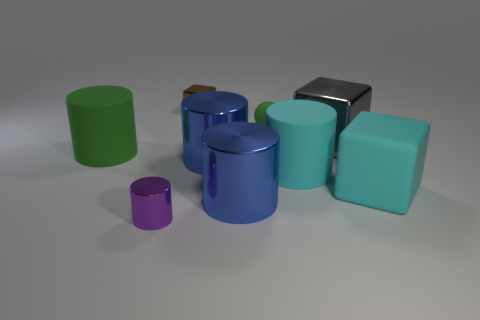Is the material of the green thing that is right of the purple shiny thing the same as the purple cylinder that is in front of the small green rubber ball?
Provide a succinct answer. No. Is there any other thing that has the same color as the tiny rubber ball?
Keep it short and to the point. Yes. What color is the small metallic thing that is the same shape as the big gray thing?
Provide a short and direct response. Brown. What size is the metal thing that is behind the matte cube and in front of the gray shiny block?
Your answer should be compact. Large. There is a small brown metallic object on the left side of the large gray block; is its shape the same as the big blue metal object behind the rubber cube?
Keep it short and to the point. No. The large object that is the same color as the big matte cube is what shape?
Your answer should be compact. Cylinder. How many large cyan things have the same material as the green sphere?
Your response must be concise. 2. There is a matte object that is both on the right side of the tiny rubber sphere and to the left of the gray metal thing; what shape is it?
Give a very brief answer. Cylinder. Are the big cyan cylinder to the right of the green ball and the cyan cube made of the same material?
Give a very brief answer. Yes. Is there any other thing that has the same material as the small ball?
Make the answer very short. Yes. 